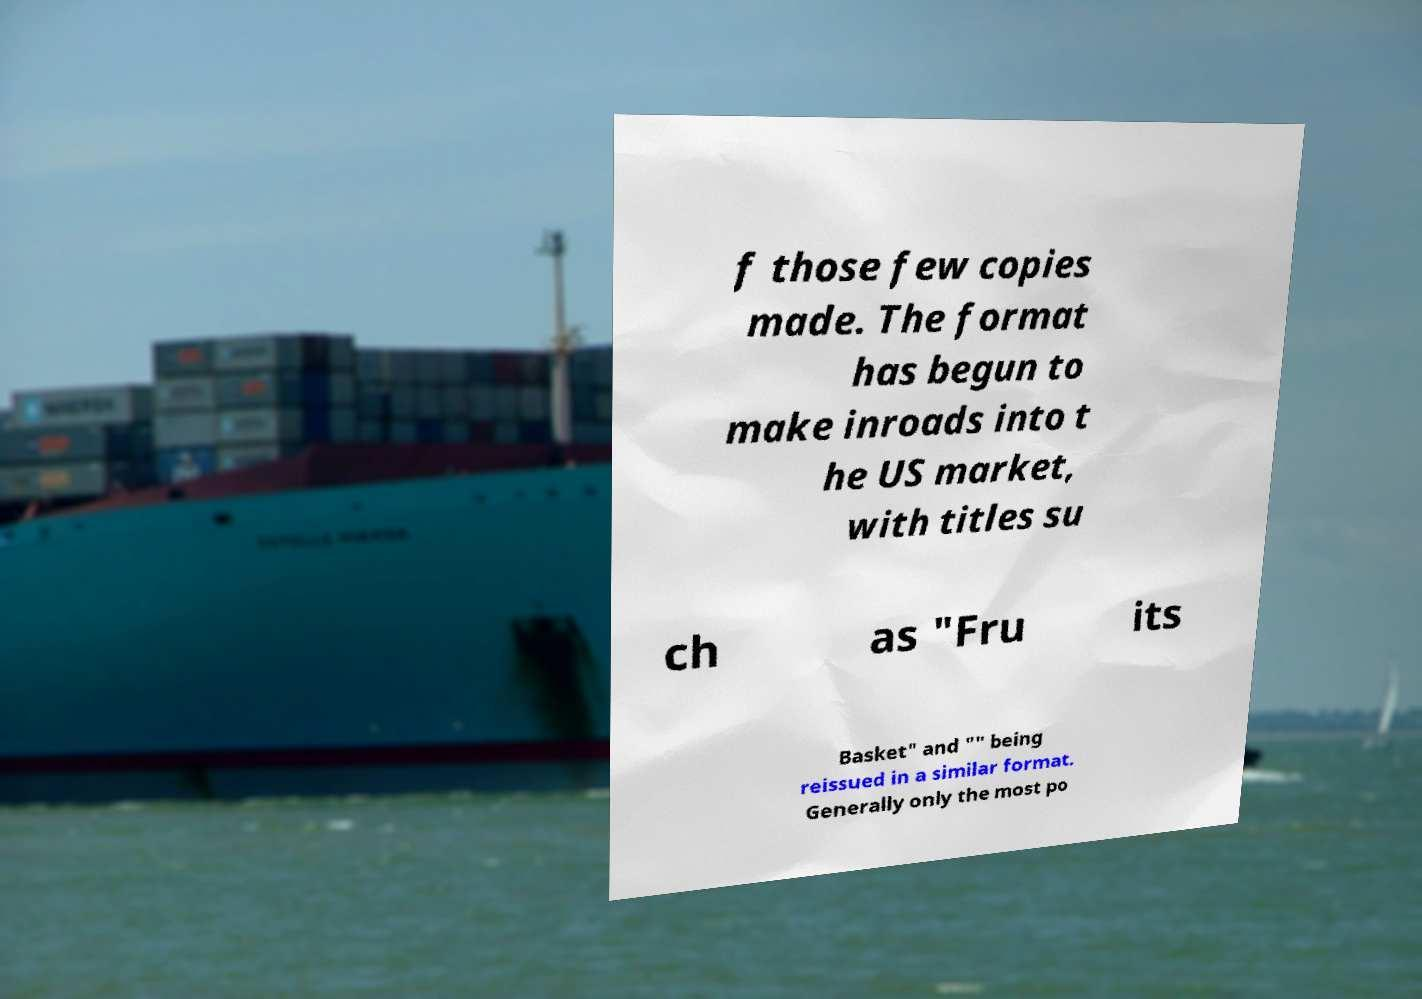For documentation purposes, I need the text within this image transcribed. Could you provide that? f those few copies made. The format has begun to make inroads into t he US market, with titles su ch as "Fru its Basket" and "" being reissued in a similar format. Generally only the most po 